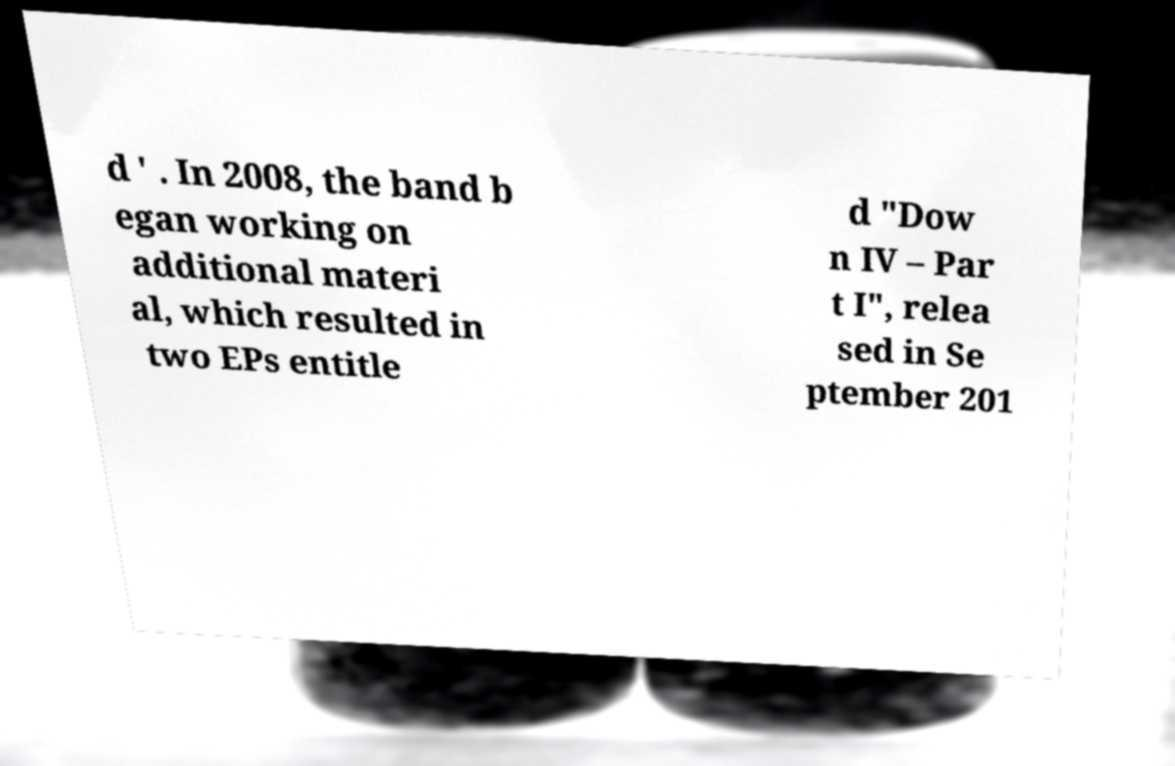There's text embedded in this image that I need extracted. Can you transcribe it verbatim? d ' . In 2008, the band b egan working on additional materi al, which resulted in two EPs entitle d "Dow n IV – Par t I", relea sed in Se ptember 201 